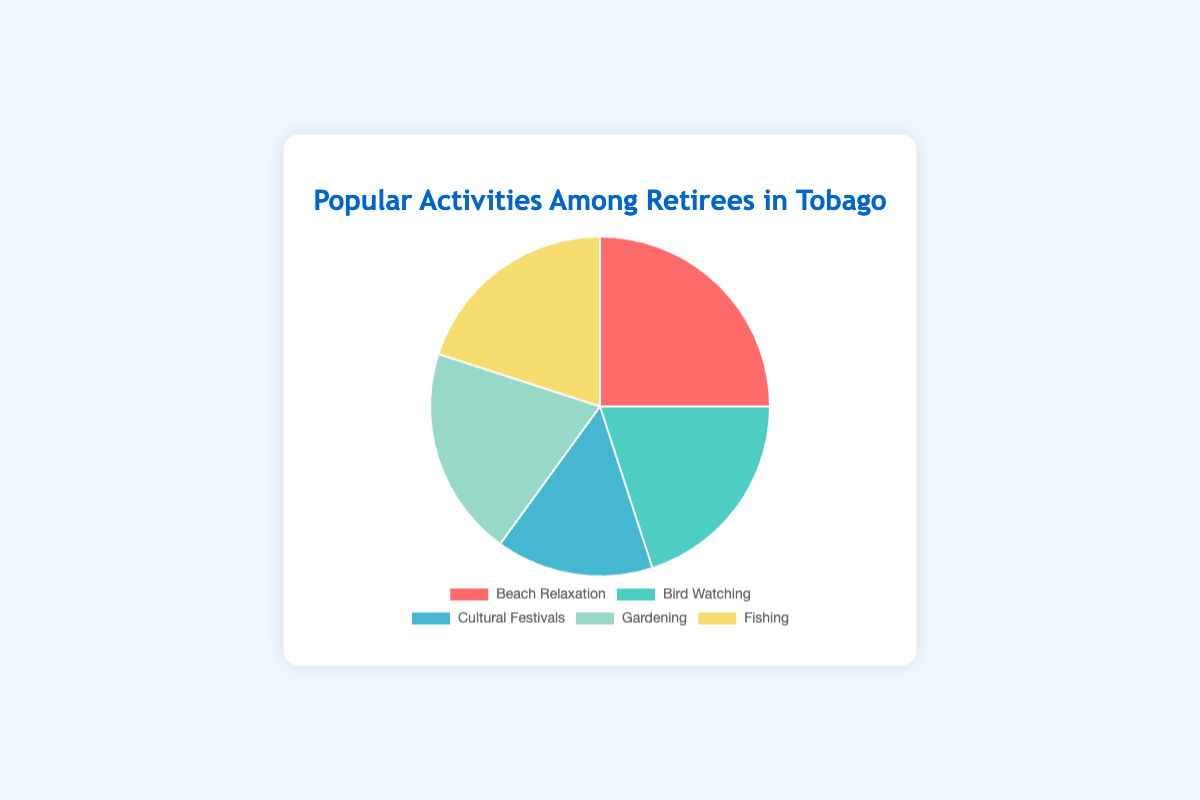What's the most popular activity among retirees in Tobago? The label with the highest percentage on the pie chart is "Beach Relaxation" with 25%.
Answer: Beach Relaxation Which activities have an equal percentage of retirees participating in them? According to the pie chart, "Bird Watching," "Gardening," and "Fishing" each have 20% participation.
Answer: Bird Watching, Gardening, and Fishing What's the total percentage of retirees involved in either cultural festivals or bird watching? The pie chart shows "Cultural Festivals" at 15% and "Bird Watching" at 20%. Adding these percentages gives 35%.
Answer: 35% Which activity occupies the smallest portion of the pie chart? The pie chart shows that "Cultural Festivals" has the smallest percentage, which is 15%.
Answer: Cultural Festivals Is the percentage of retirees who enjoy gardening the same as those who enjoy fishing? The pie chart illustrates that both "Gardening" and "Fishing" have a 20% share.
Answer: Yes How much more popular is Beach Relaxation compared to Cultural Festivals? The percentage for "Beach Relaxation" is 25% and for "Cultural Festivals" it is 15%. The difference is 10%.
Answer: 10% What fraction of the activities have a participation rate of 20%? Out of five activities, three have a participation rate of 20%. This is 3/5 or 60%.
Answer: 60% What is the average percentage of participation for the three activities "Bird Watching," "Gardening," and "Fishing"? Each of these three activities has a 20% participation rate. The sum of these percentages is 60%, and the average is 60% divided by 3, which equals 20%.
Answer: 20% How much of the pie chart is occupied by activities other than Beach Relaxation? The percentage for activities other than Beach Relaxation is the sum of "Bird Watching," "Cultural Festivals," "Gardening," and "Fishing", which is 20% + 15% + 20% + 20% = 75%.
Answer: 75% 